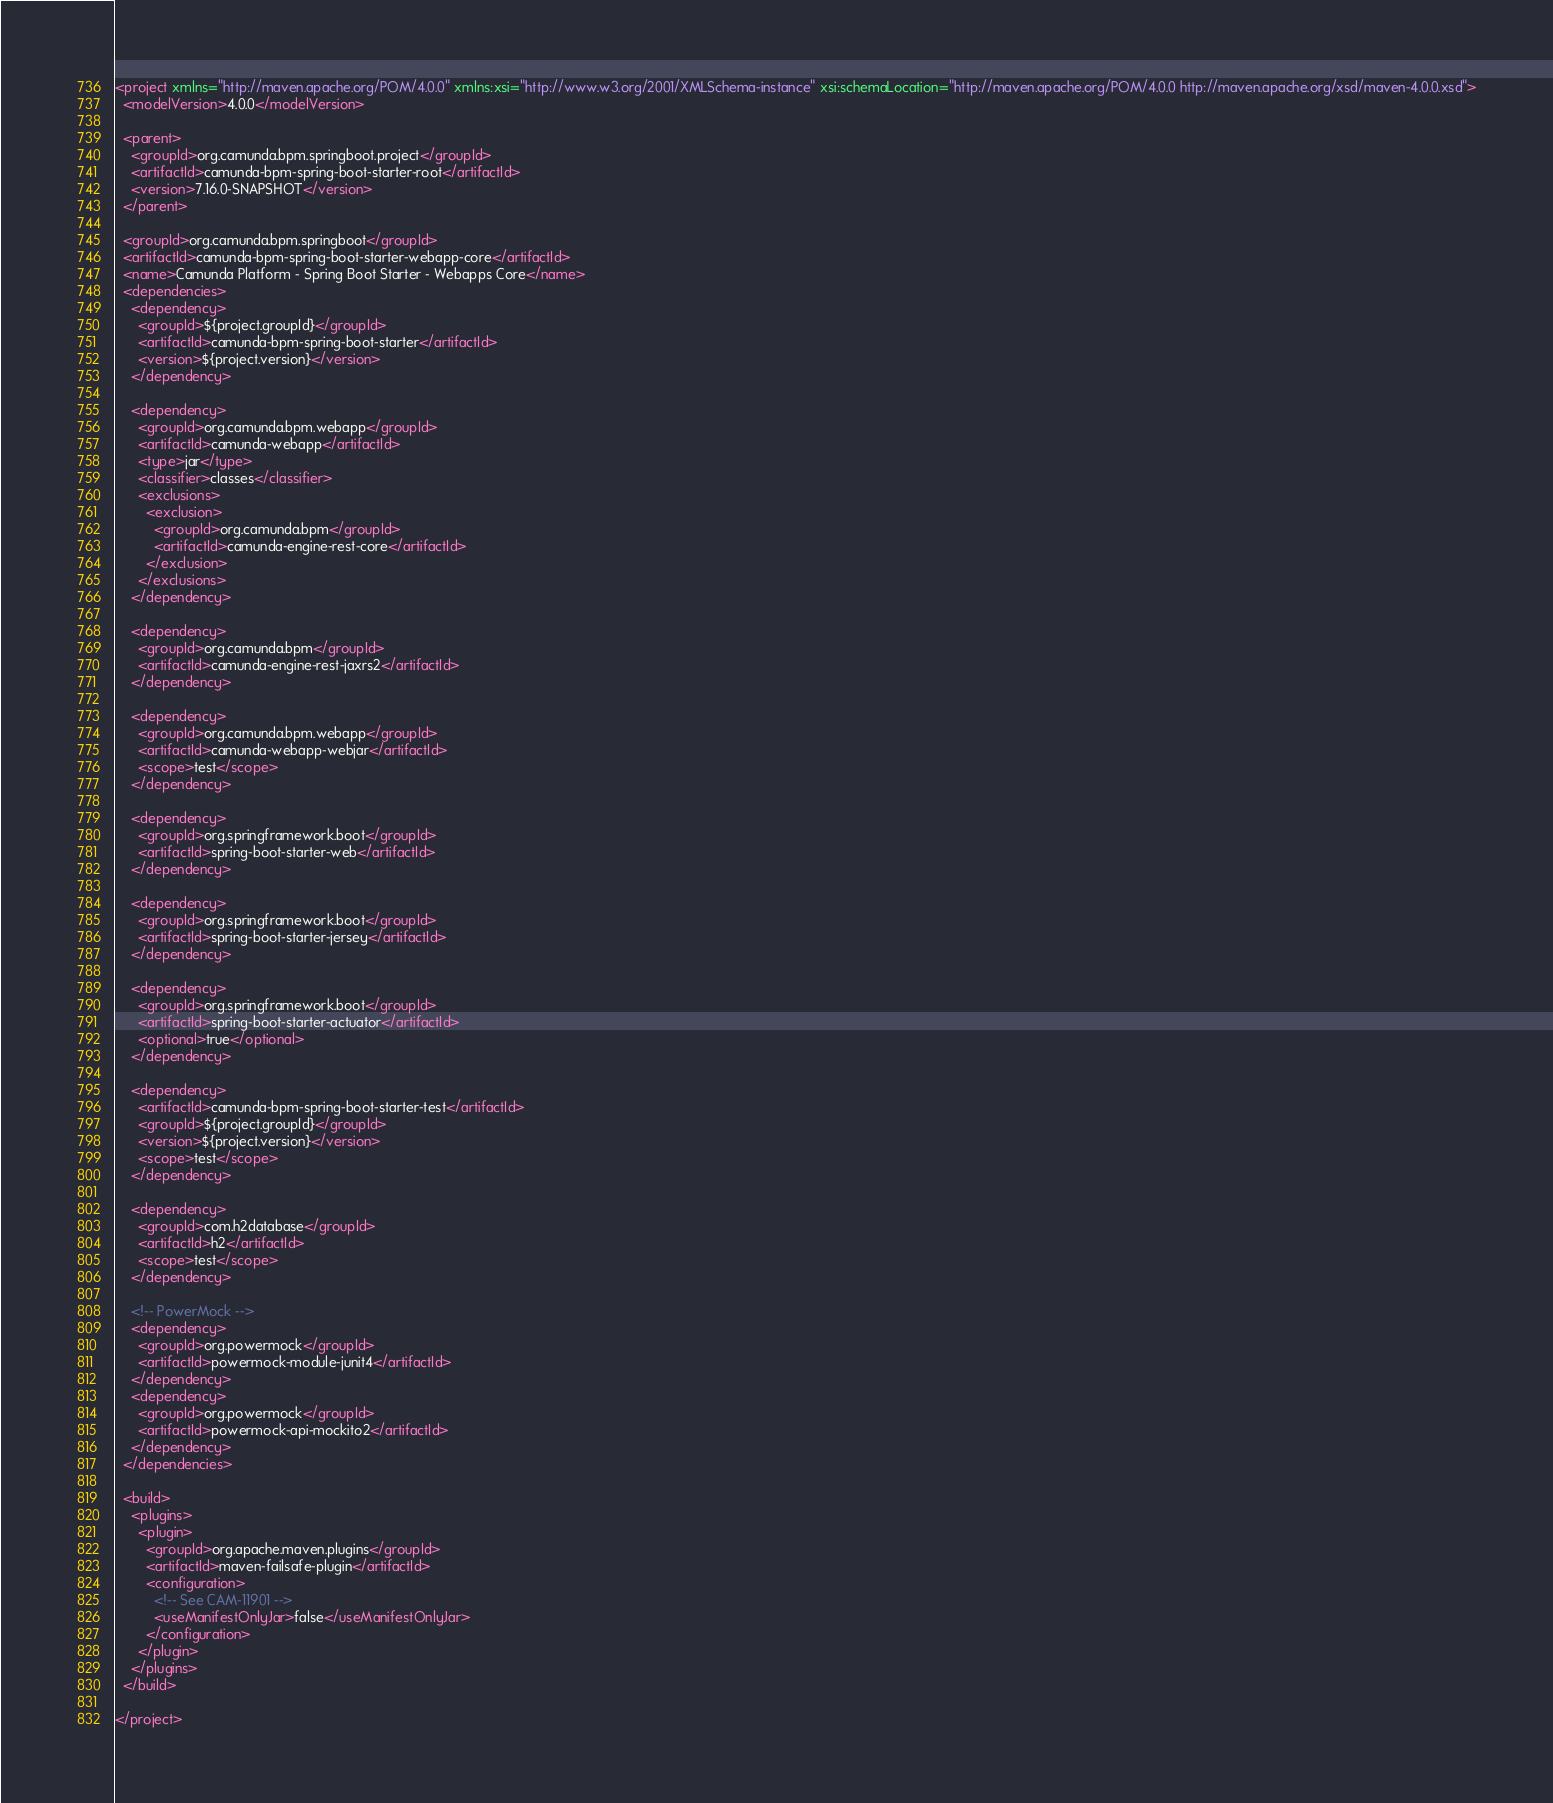Convert code to text. <code><loc_0><loc_0><loc_500><loc_500><_XML_><project xmlns="http://maven.apache.org/POM/4.0.0" xmlns:xsi="http://www.w3.org/2001/XMLSchema-instance" xsi:schemaLocation="http://maven.apache.org/POM/4.0.0 http://maven.apache.org/xsd/maven-4.0.0.xsd">
  <modelVersion>4.0.0</modelVersion>

  <parent>
    <groupId>org.camunda.bpm.springboot.project</groupId>
    <artifactId>camunda-bpm-spring-boot-starter-root</artifactId>
    <version>7.16.0-SNAPSHOT</version>
  </parent>

  <groupId>org.camunda.bpm.springboot</groupId>
  <artifactId>camunda-bpm-spring-boot-starter-webapp-core</artifactId>
  <name>Camunda Platform - Spring Boot Starter - Webapps Core</name>
  <dependencies>
    <dependency>
      <groupId>${project.groupId}</groupId>
      <artifactId>camunda-bpm-spring-boot-starter</artifactId>
      <version>${project.version}</version>
    </dependency>

    <dependency>
      <groupId>org.camunda.bpm.webapp</groupId>
      <artifactId>camunda-webapp</artifactId>
      <type>jar</type>
      <classifier>classes</classifier>
      <exclusions>
        <exclusion>
          <groupId>org.camunda.bpm</groupId>
          <artifactId>camunda-engine-rest-core</artifactId>
        </exclusion>
      </exclusions>
    </dependency>

    <dependency>
      <groupId>org.camunda.bpm</groupId>
      <artifactId>camunda-engine-rest-jaxrs2</artifactId>
    </dependency>

    <dependency>
      <groupId>org.camunda.bpm.webapp</groupId>
      <artifactId>camunda-webapp-webjar</artifactId>
      <scope>test</scope>
    </dependency>

    <dependency>
      <groupId>org.springframework.boot</groupId>
      <artifactId>spring-boot-starter-web</artifactId>
    </dependency>

    <dependency>
      <groupId>org.springframework.boot</groupId>
      <artifactId>spring-boot-starter-jersey</artifactId>
    </dependency>

    <dependency>
      <groupId>org.springframework.boot</groupId>
      <artifactId>spring-boot-starter-actuator</artifactId>
      <optional>true</optional>
    </dependency>

    <dependency>
      <artifactId>camunda-bpm-spring-boot-starter-test</artifactId>
      <groupId>${project.groupId}</groupId>
      <version>${project.version}</version>
      <scope>test</scope>
    </dependency>

    <dependency>
      <groupId>com.h2database</groupId>
      <artifactId>h2</artifactId>
      <scope>test</scope>
    </dependency>

    <!-- PowerMock -->
    <dependency>
      <groupId>org.powermock</groupId>
      <artifactId>powermock-module-junit4</artifactId>
    </dependency>
    <dependency>
      <groupId>org.powermock</groupId>
      <artifactId>powermock-api-mockito2</artifactId>
    </dependency>
  </dependencies>

  <build>
    <plugins>
      <plugin>
        <groupId>org.apache.maven.plugins</groupId>
        <artifactId>maven-failsafe-plugin</artifactId>
        <configuration>
          <!-- See CAM-11901 -->
          <useManifestOnlyJar>false</useManifestOnlyJar>
        </configuration>
      </plugin>
    </plugins>
  </build>

</project>
</code> 